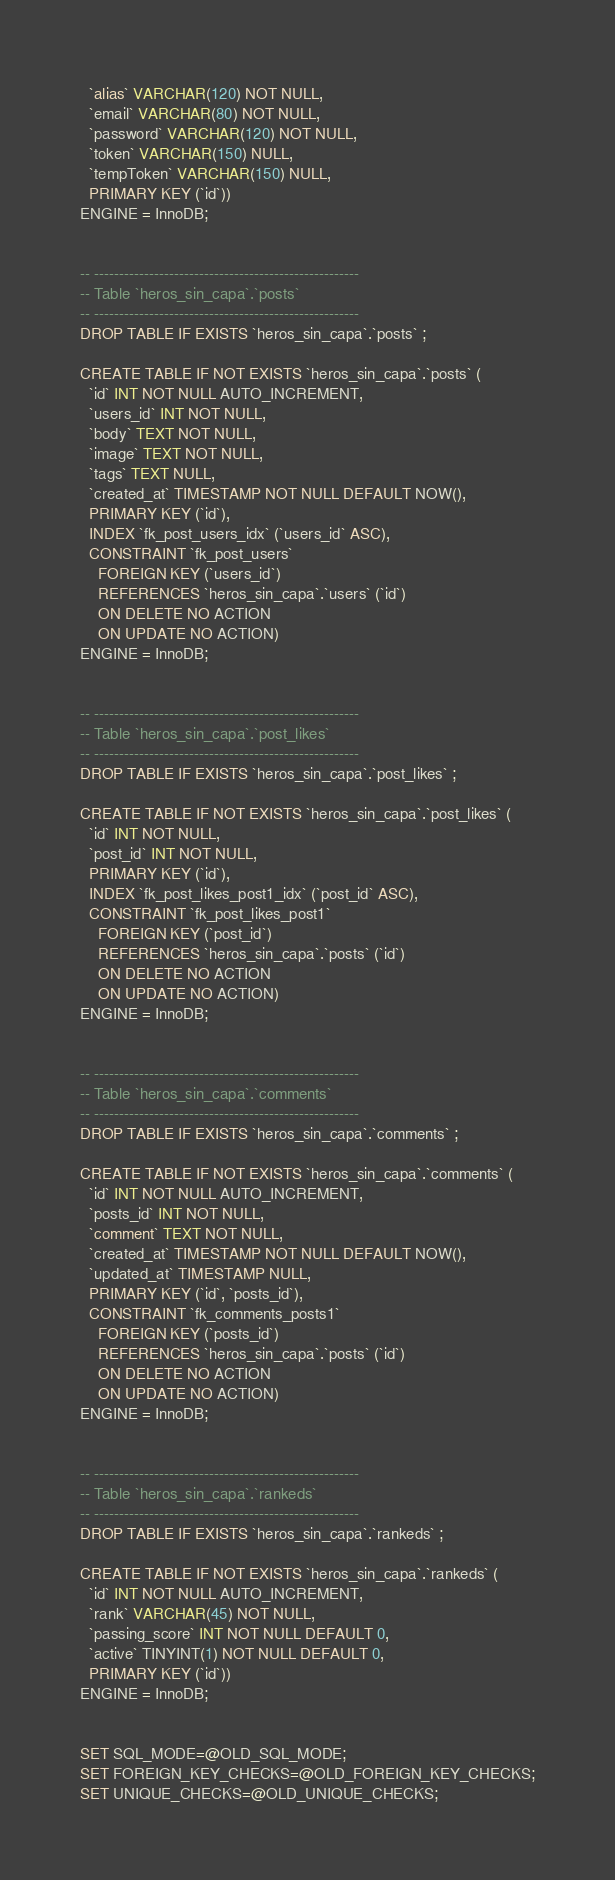Convert code to text. <code><loc_0><loc_0><loc_500><loc_500><_SQL_>  `alias` VARCHAR(120) NOT NULL,
  `email` VARCHAR(80) NOT NULL,
  `password` VARCHAR(120) NOT NULL,
  `token` VARCHAR(150) NULL,
  `tempToken` VARCHAR(150) NULL,
  PRIMARY KEY (`id`))
ENGINE = InnoDB;


-- -----------------------------------------------------
-- Table `heros_sin_capa`.`posts`
-- -----------------------------------------------------
DROP TABLE IF EXISTS `heros_sin_capa`.`posts` ;

CREATE TABLE IF NOT EXISTS `heros_sin_capa`.`posts` (
  `id` INT NOT NULL AUTO_INCREMENT,
  `users_id` INT NOT NULL,
  `body` TEXT NOT NULL,
  `image` TEXT NOT NULL,
  `tags` TEXT NULL,
  `created_at` TIMESTAMP NOT NULL DEFAULT NOW(),
  PRIMARY KEY (`id`),
  INDEX `fk_post_users_idx` (`users_id` ASC),
  CONSTRAINT `fk_post_users`
    FOREIGN KEY (`users_id`)
    REFERENCES `heros_sin_capa`.`users` (`id`)
    ON DELETE NO ACTION
    ON UPDATE NO ACTION)
ENGINE = InnoDB;


-- -----------------------------------------------------
-- Table `heros_sin_capa`.`post_likes`
-- -----------------------------------------------------
DROP TABLE IF EXISTS `heros_sin_capa`.`post_likes` ;

CREATE TABLE IF NOT EXISTS `heros_sin_capa`.`post_likes` (
  `id` INT NOT NULL,
  `post_id` INT NOT NULL,
  PRIMARY KEY (`id`),
  INDEX `fk_post_likes_post1_idx` (`post_id` ASC),
  CONSTRAINT `fk_post_likes_post1`
    FOREIGN KEY (`post_id`)
    REFERENCES `heros_sin_capa`.`posts` (`id`)
    ON DELETE NO ACTION
    ON UPDATE NO ACTION)
ENGINE = InnoDB;


-- -----------------------------------------------------
-- Table `heros_sin_capa`.`comments`
-- -----------------------------------------------------
DROP TABLE IF EXISTS `heros_sin_capa`.`comments` ;

CREATE TABLE IF NOT EXISTS `heros_sin_capa`.`comments` (
  `id` INT NOT NULL AUTO_INCREMENT,
  `posts_id` INT NOT NULL,
  `comment` TEXT NOT NULL,
  `created_at` TIMESTAMP NOT NULL DEFAULT NOW(),
  `updated_at` TIMESTAMP NULL,
  PRIMARY KEY (`id`, `posts_id`),
  CONSTRAINT `fk_comments_posts1`
    FOREIGN KEY (`posts_id`)
    REFERENCES `heros_sin_capa`.`posts` (`id`)
    ON DELETE NO ACTION
    ON UPDATE NO ACTION)
ENGINE = InnoDB;


-- -----------------------------------------------------
-- Table `heros_sin_capa`.`rankeds`
-- -----------------------------------------------------
DROP TABLE IF EXISTS `heros_sin_capa`.`rankeds` ;

CREATE TABLE IF NOT EXISTS `heros_sin_capa`.`rankeds` (
  `id` INT NOT NULL AUTO_INCREMENT,
  `rank` VARCHAR(45) NOT NULL,
  `passing_score` INT NOT NULL DEFAULT 0,
  `active` TINYINT(1) NOT NULL DEFAULT 0,
  PRIMARY KEY (`id`))
ENGINE = InnoDB;


SET SQL_MODE=@OLD_SQL_MODE;
SET FOREIGN_KEY_CHECKS=@OLD_FOREIGN_KEY_CHECKS;
SET UNIQUE_CHECKS=@OLD_UNIQUE_CHECKS;
</code> 